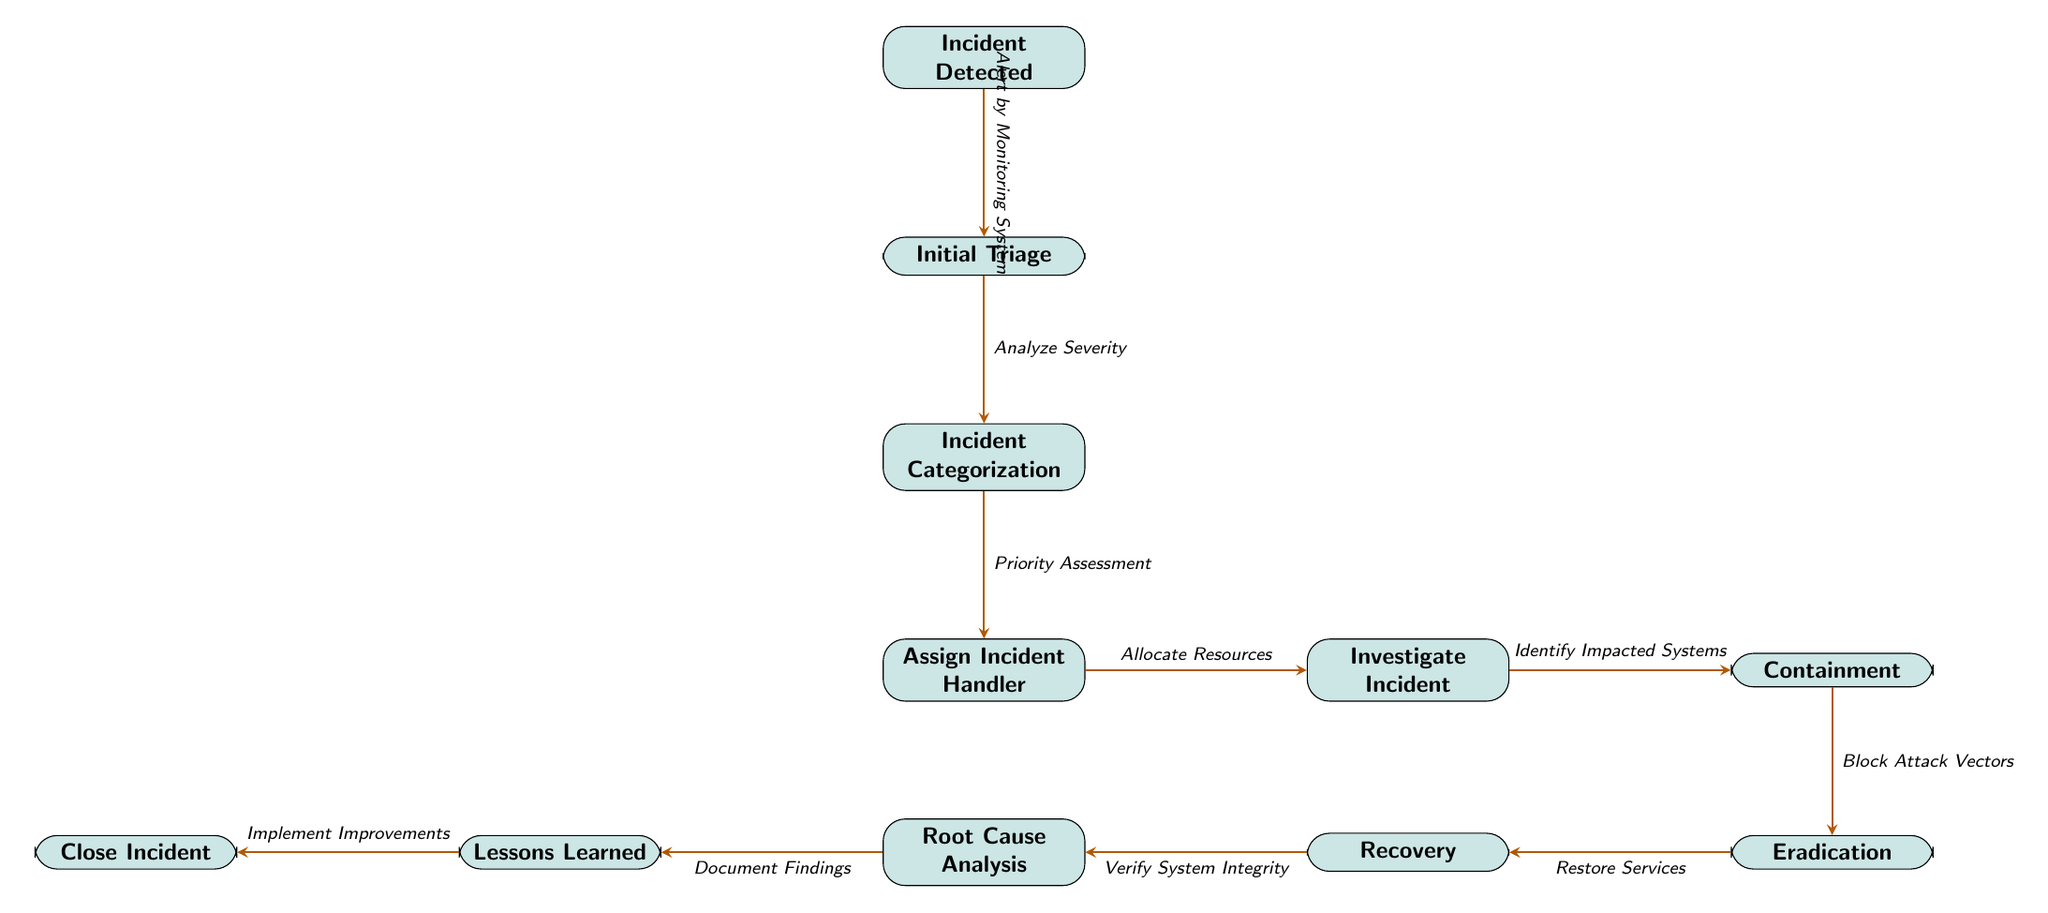What is the first step in the incident response process? The first node in the diagram indicates "Incident Detected," which represents the initial stage of the incident response process.
Answer: Incident Detected How many nodes are there in the diagram? By counting the individual rectangular nodes defined in the diagram, there are a total of 11 nodes present in the incident response flowchart.
Answer: 11 What action occurs after the initial triage? The flow of the diagram indicates that the step following "Initial Triage" is "Incident Categorization," and this establishes the subsequent action taken according to the incident response workflow.
Answer: Incident Categorization What is the main goal of the "Containment" step? The label for the node indicates that "Containment" focuses on the action of blocking attack vectors, which is crucial to prevent further impacts from the incident.
Answer: Block Attack Vectors Which step leads to "Lessons Learned"? The diagram shows the progression of steps leading to "Lessons Learned," with "Root Cause Analysis" being the direct precursor that helps determine the insights from the incident for future prevention.
Answer: Root Cause Analysis What type of assessment is conducted after incident categorization? The diagram shows that "Priority Assessment" follows "Incident Categorization," which identifies the urgency of the incident for handling and response decisions.
Answer: Priority Assessment What does the arrow from "Close Incident" to "Implement Improvements" signify? The arrow indicates a direct relationship where "Implement Improvements" is the actionable step that follows the closure of an incident, denoting the organization's commitment to applying lessons from the incident.
Answer: Implement Improvements After "Eradication," what is the next step in the incident response process? The sequence of the flowchart shows that the next node following "Eradication" is "Recovery," which involves restoring systems after a successful eradication of the threat.
Answer: Recovery 